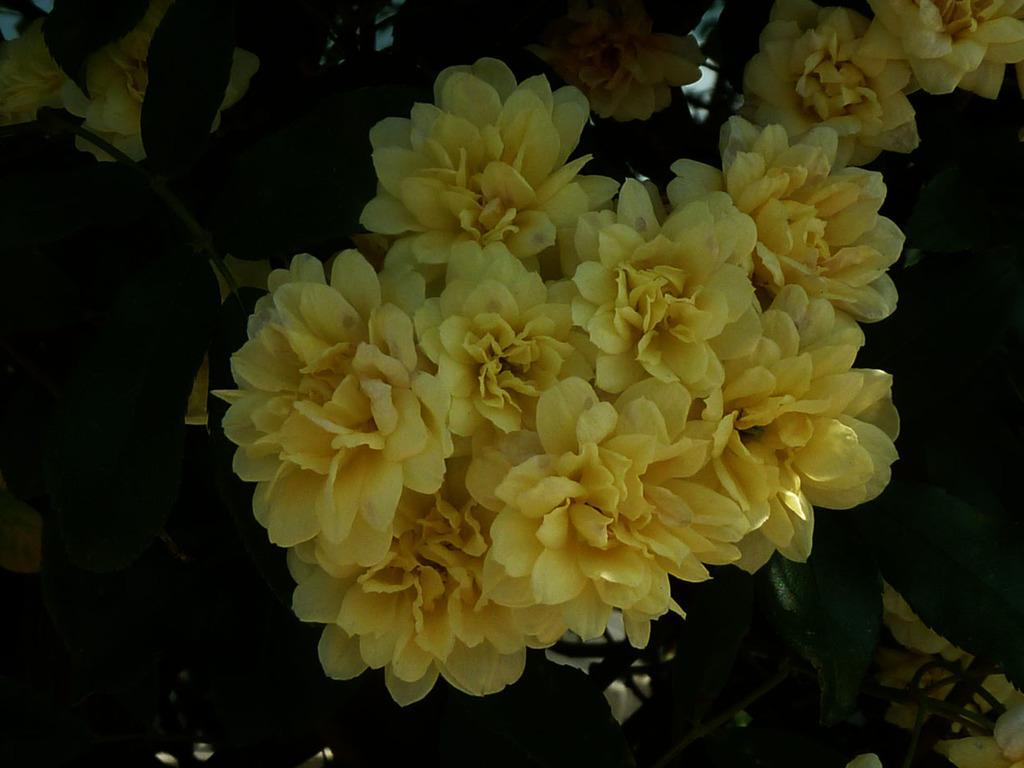Could you give a brief overview of what you see in this image? In this picture I can see leaves and flowers. 